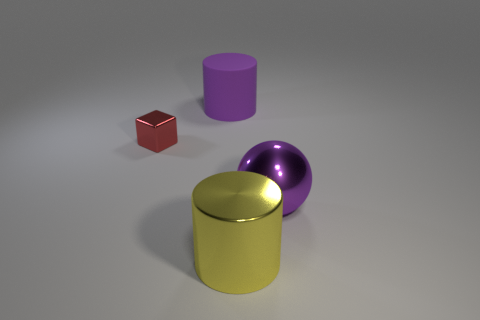Add 1 tiny purple objects. How many objects exist? 5 Subtract all large brown rubber spheres. Subtract all large purple objects. How many objects are left? 2 Add 3 purple shiny things. How many purple shiny things are left? 4 Add 1 big objects. How many big objects exist? 4 Subtract 0 gray balls. How many objects are left? 4 